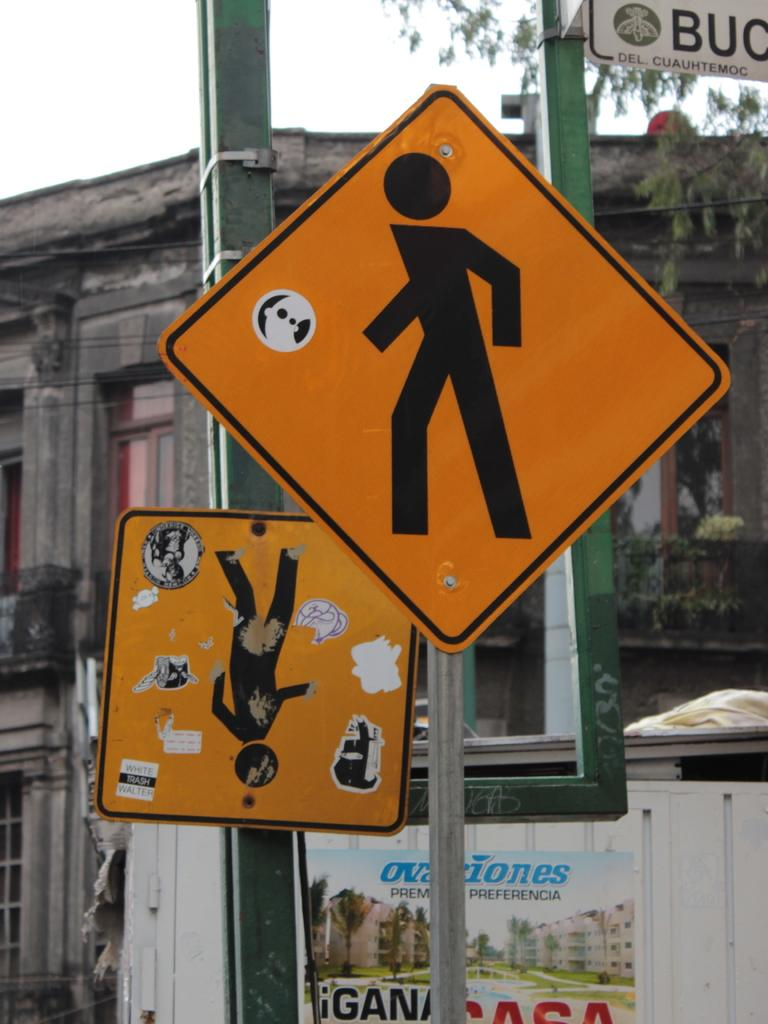Provide a one-sentence caption for the provided image. A city street is lined with signs where one says preferencia and a sign that says del, cuauhtemoc on it. 